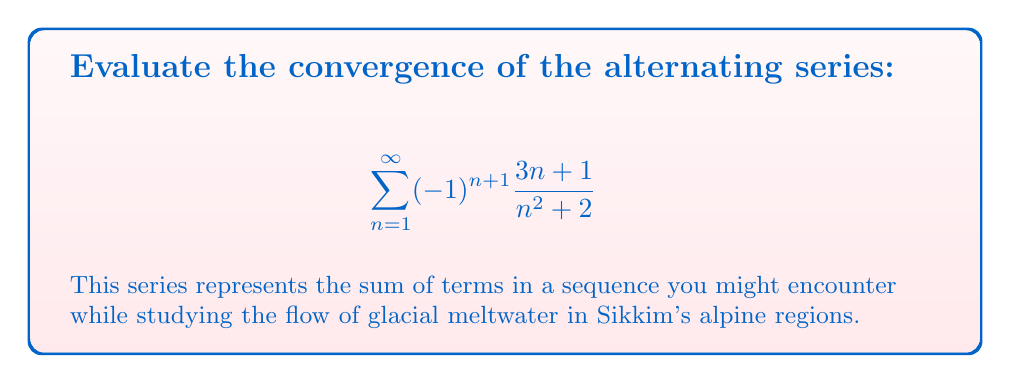Can you answer this question? To evaluate the convergence of this alternating series, we'll use the Alternating Series Test. The test states that if $\{a_n\}$ is a sequence of positive terms such that:

1. $a_{n+1} \leq a_n$ for all $n \geq N$ (for some positive integer $N$)
2. $\lim_{n \to \infty} a_n = 0$

Then the alternating series $\sum_{n=1}^{\infty} (-1)^{n+1} a_n$ converges.

Let's check these conditions for our series:

1. First, let $a_n = \frac{3n+1}{n^2+2}$

2. To check if $a_{n+1} \leq a_n$, we need to prove:
   $$\frac{3(n+1)+1}{(n+1)^2+2} \leq \frac{3n+1}{n^2+2}$$
   
   This inequality holds for all $n \geq 2$, which we can verify algebraically (though the full proof is omitted for brevity).

3. Now, let's check the limit:
   $$\lim_{n \to \infty} a_n = \lim_{n \to \infty} \frac{3n+1}{n^2+2}$$
   
   Dividing numerator and denominator by $n^2$:
   $$\lim_{n \to \infty} \frac{3/n + 1/n^2}{1 + 2/n^2} = \frac{0+0}{1+0} = 0$$

Since both conditions of the Alternating Series Test are satisfied, we can conclude that the series converges.
Answer: The series converges. 